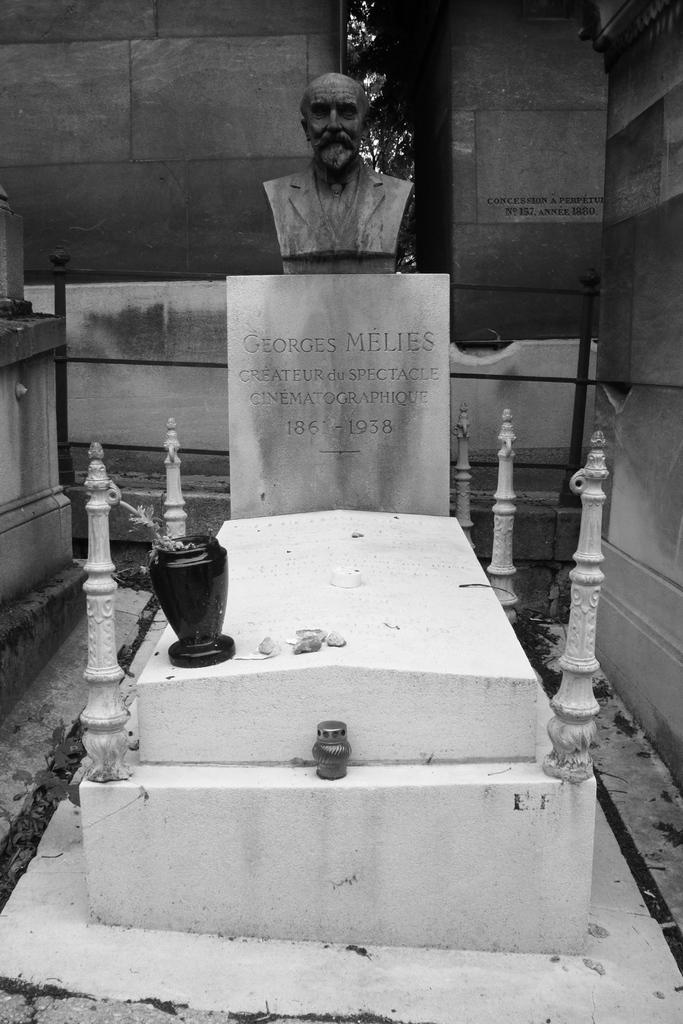What is the color scheme of the image? The image is black and white. What is the main subject of the image? There is a graveyard in the image. What can be seen within the graveyard? There is a sculpture of a person in the graveyard. What is visible in the background of the image? There is a wall in the background of the image. How many books are stacked on the drain in the image? There are no books or drains present in the image; it features a graveyard with a sculpture and a wall in the background. 